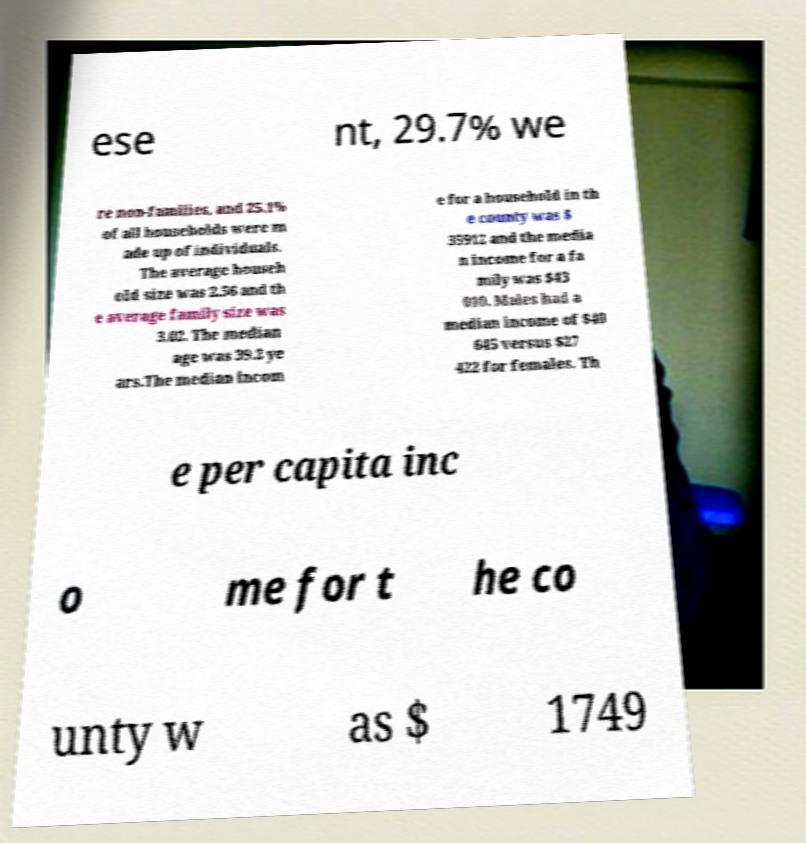Could you assist in decoding the text presented in this image and type it out clearly? ese nt, 29.7% we re non-families, and 25.1% of all households were m ade up of individuals. The average househ old size was 2.56 and th e average family size was 3.02. The median age was 39.2 ye ars.The median incom e for a household in th e county was $ 35912 and the media n income for a fa mily was $43 010. Males had a median income of $40 645 versus $27 422 for females. Th e per capita inc o me for t he co unty w as $ 1749 